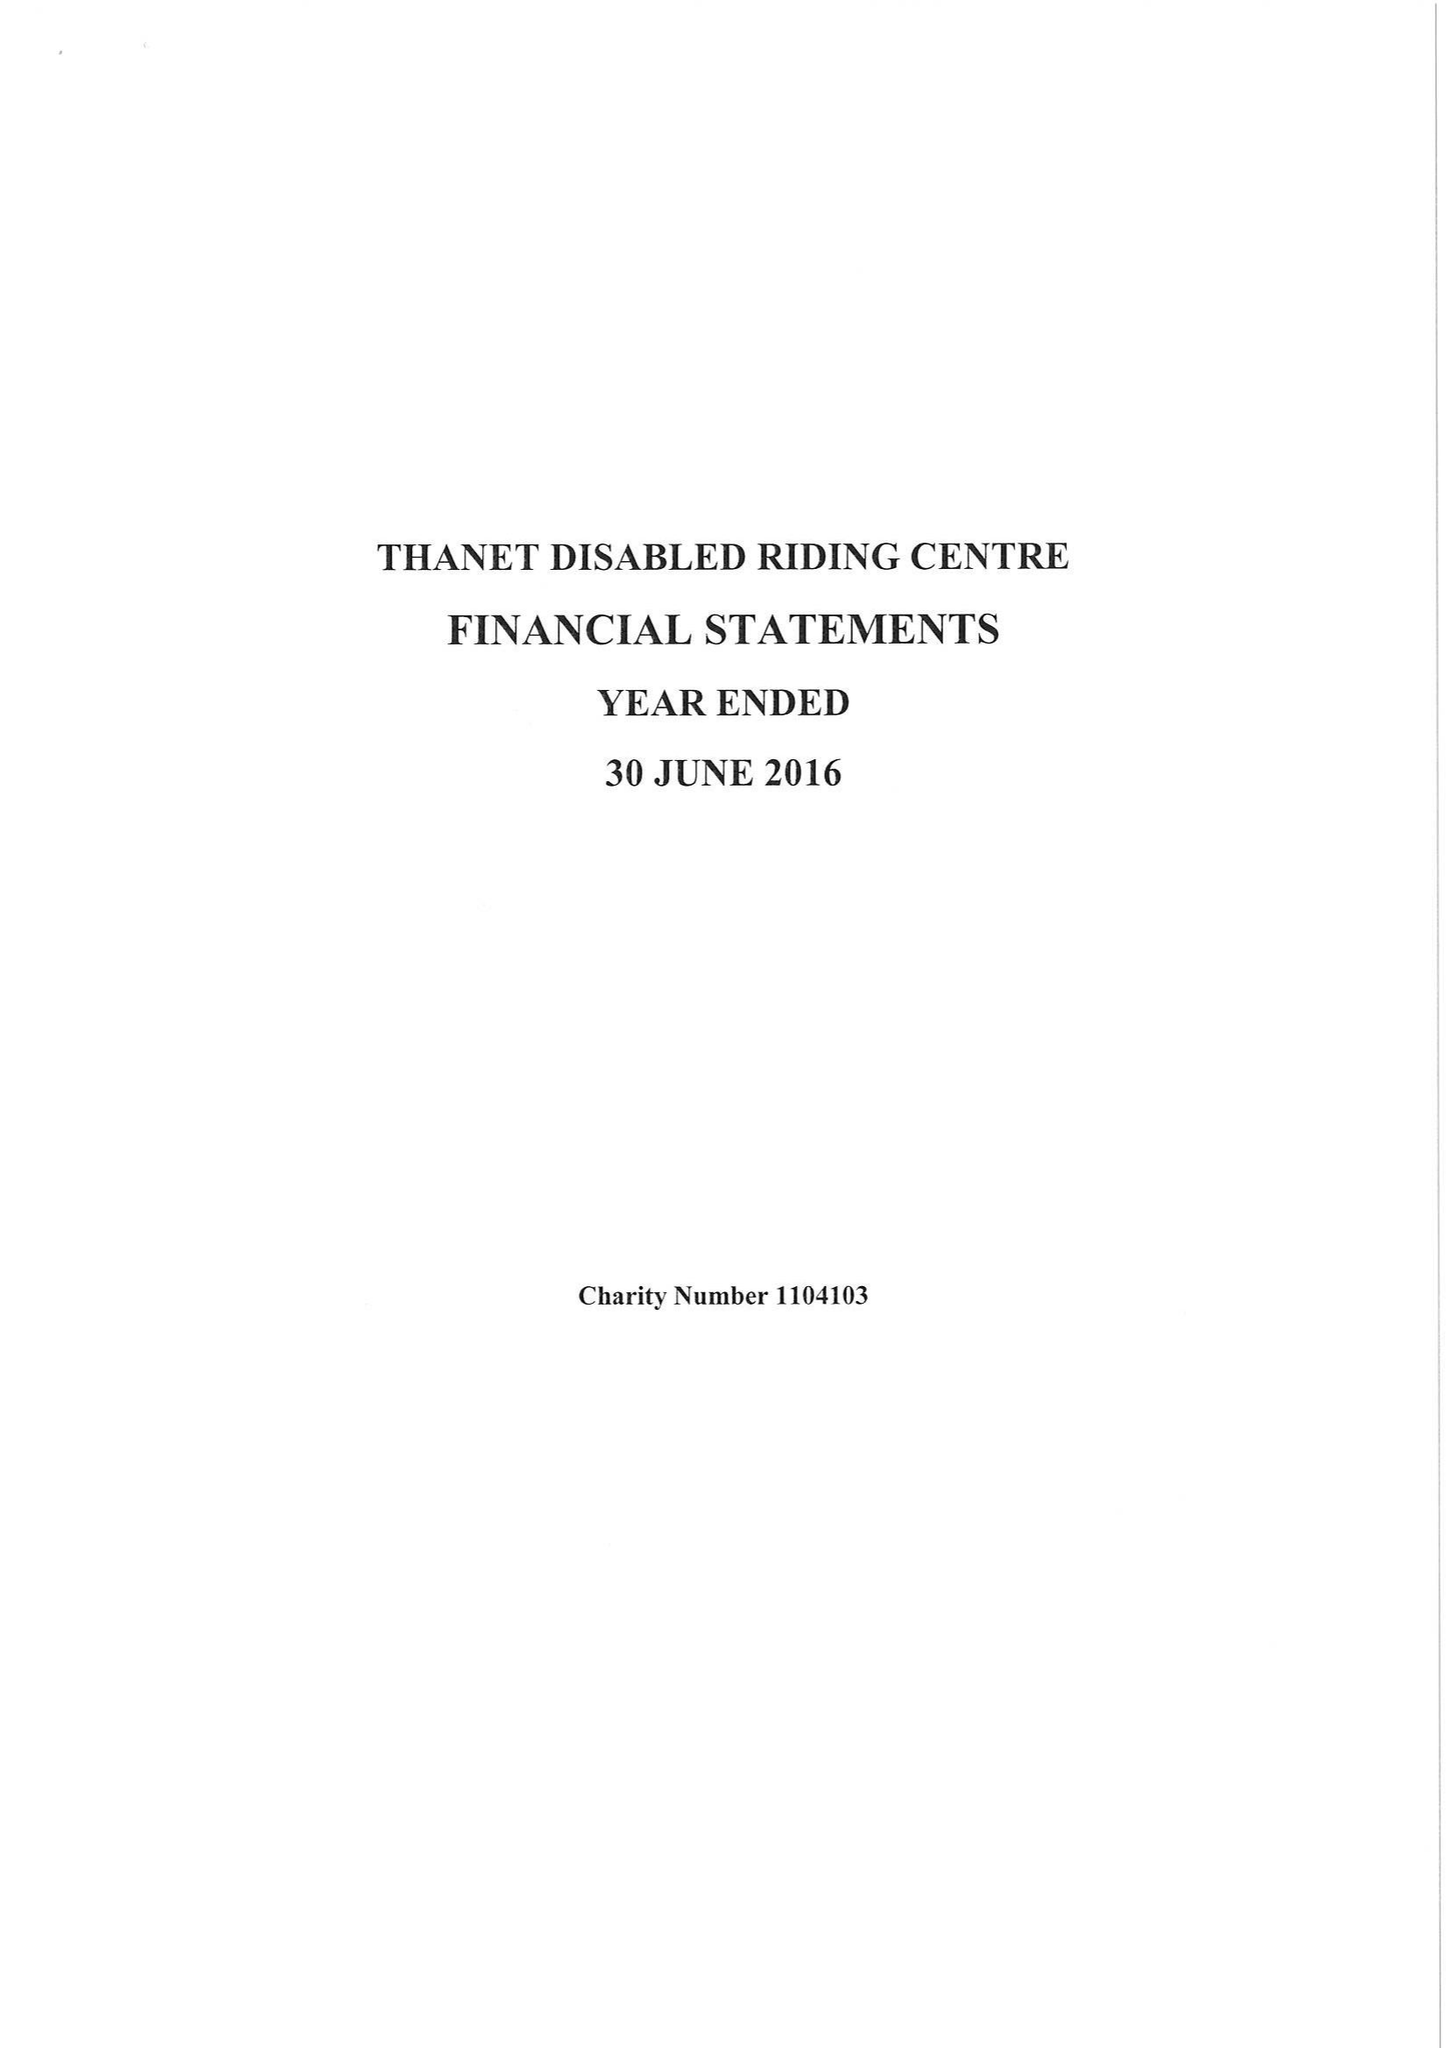What is the value for the address__street_line?
Answer the question using a single word or phrase. 3 LLOYD ROAD 